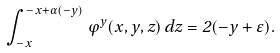<formula> <loc_0><loc_0><loc_500><loc_500>\int _ { - x } ^ { - x + \alpha ( - y ) } \varphi ^ { y } ( x , y , z ) \, d z = 2 ( - y + \varepsilon ) .</formula> 